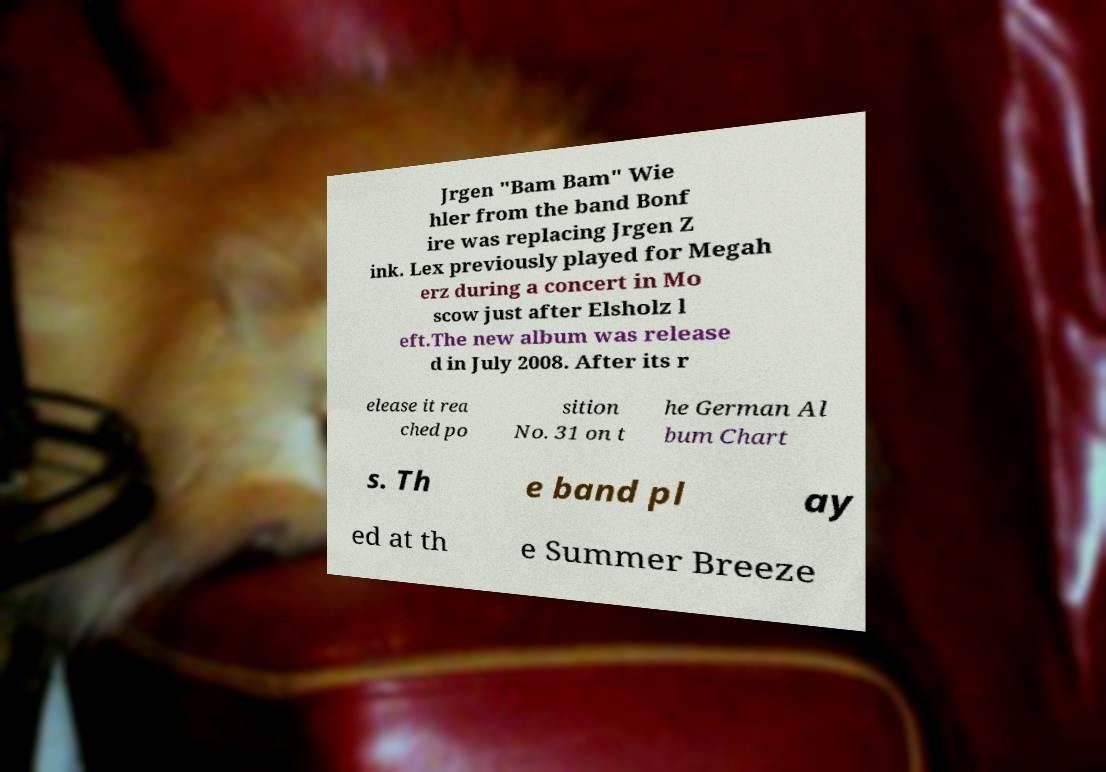Can you read and provide the text displayed in the image?This photo seems to have some interesting text. Can you extract and type it out for me? Jrgen "Bam Bam" Wie hler from the band Bonf ire was replacing Jrgen Z ink. Lex previously played for Megah erz during a concert in Mo scow just after Elsholz l eft.The new album was release d in July 2008. After its r elease it rea ched po sition No. 31 on t he German Al bum Chart s. Th e band pl ay ed at th e Summer Breeze 